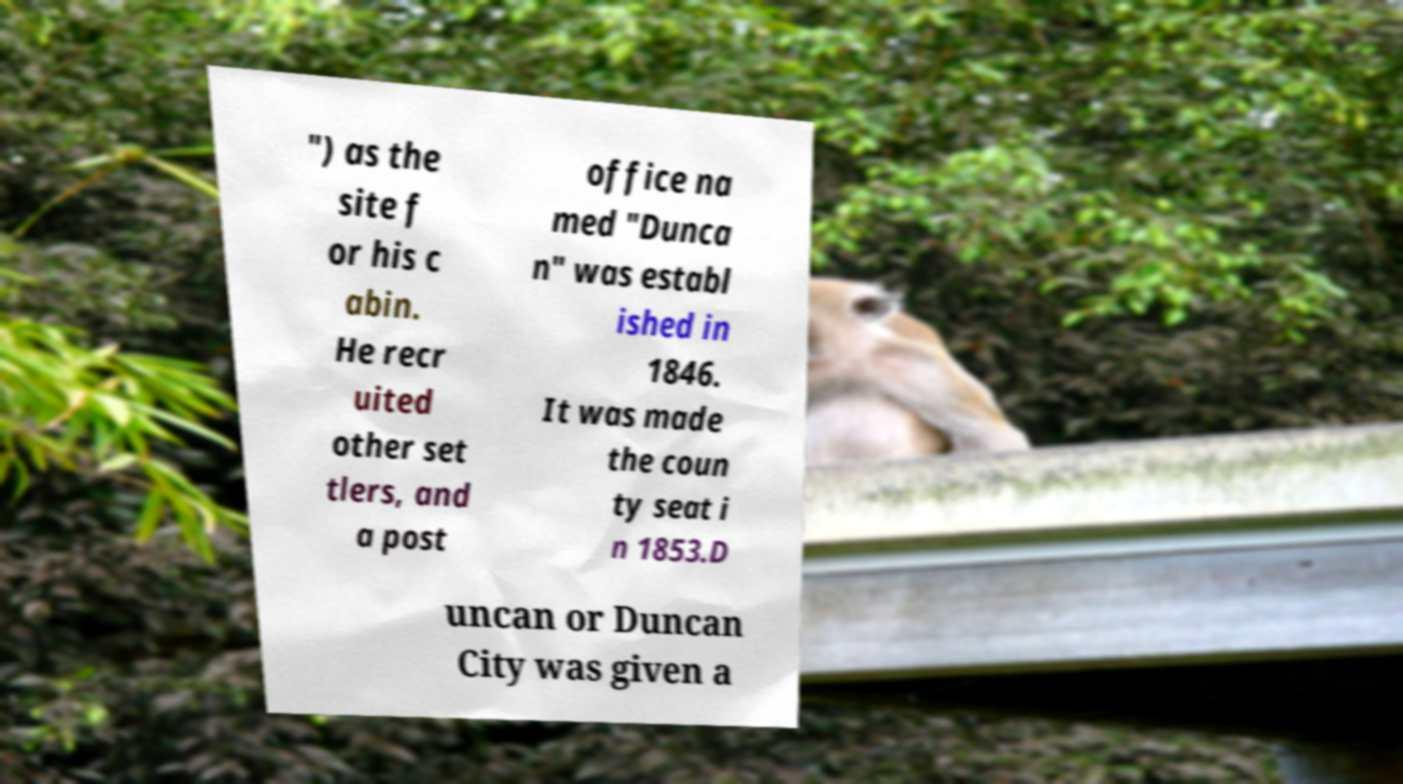What messages or text are displayed in this image? I need them in a readable, typed format. ") as the site f or his c abin. He recr uited other set tlers, and a post office na med "Dunca n" was establ ished in 1846. It was made the coun ty seat i n 1853.D uncan or Duncan City was given a 